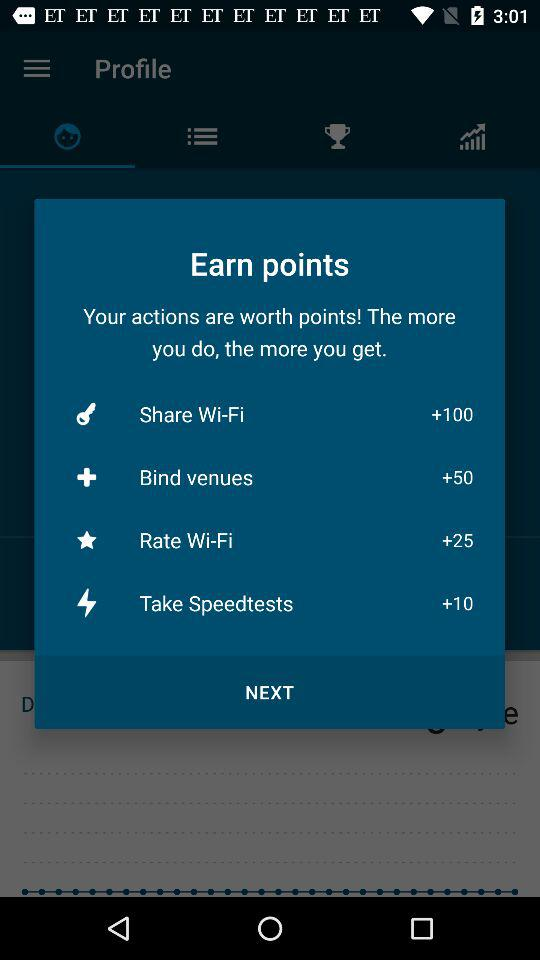What can I do to earn points, and how many points do I get for each action? You can earn points through various actions. Sharing Wi-Fi gives you 100 points, binding venues earns you 50 points, rating Wi-Fi yields 25 points, and taking speed tests awards you 10 points. Each action contributes differently to your point total, encouraging a range of contributions. 